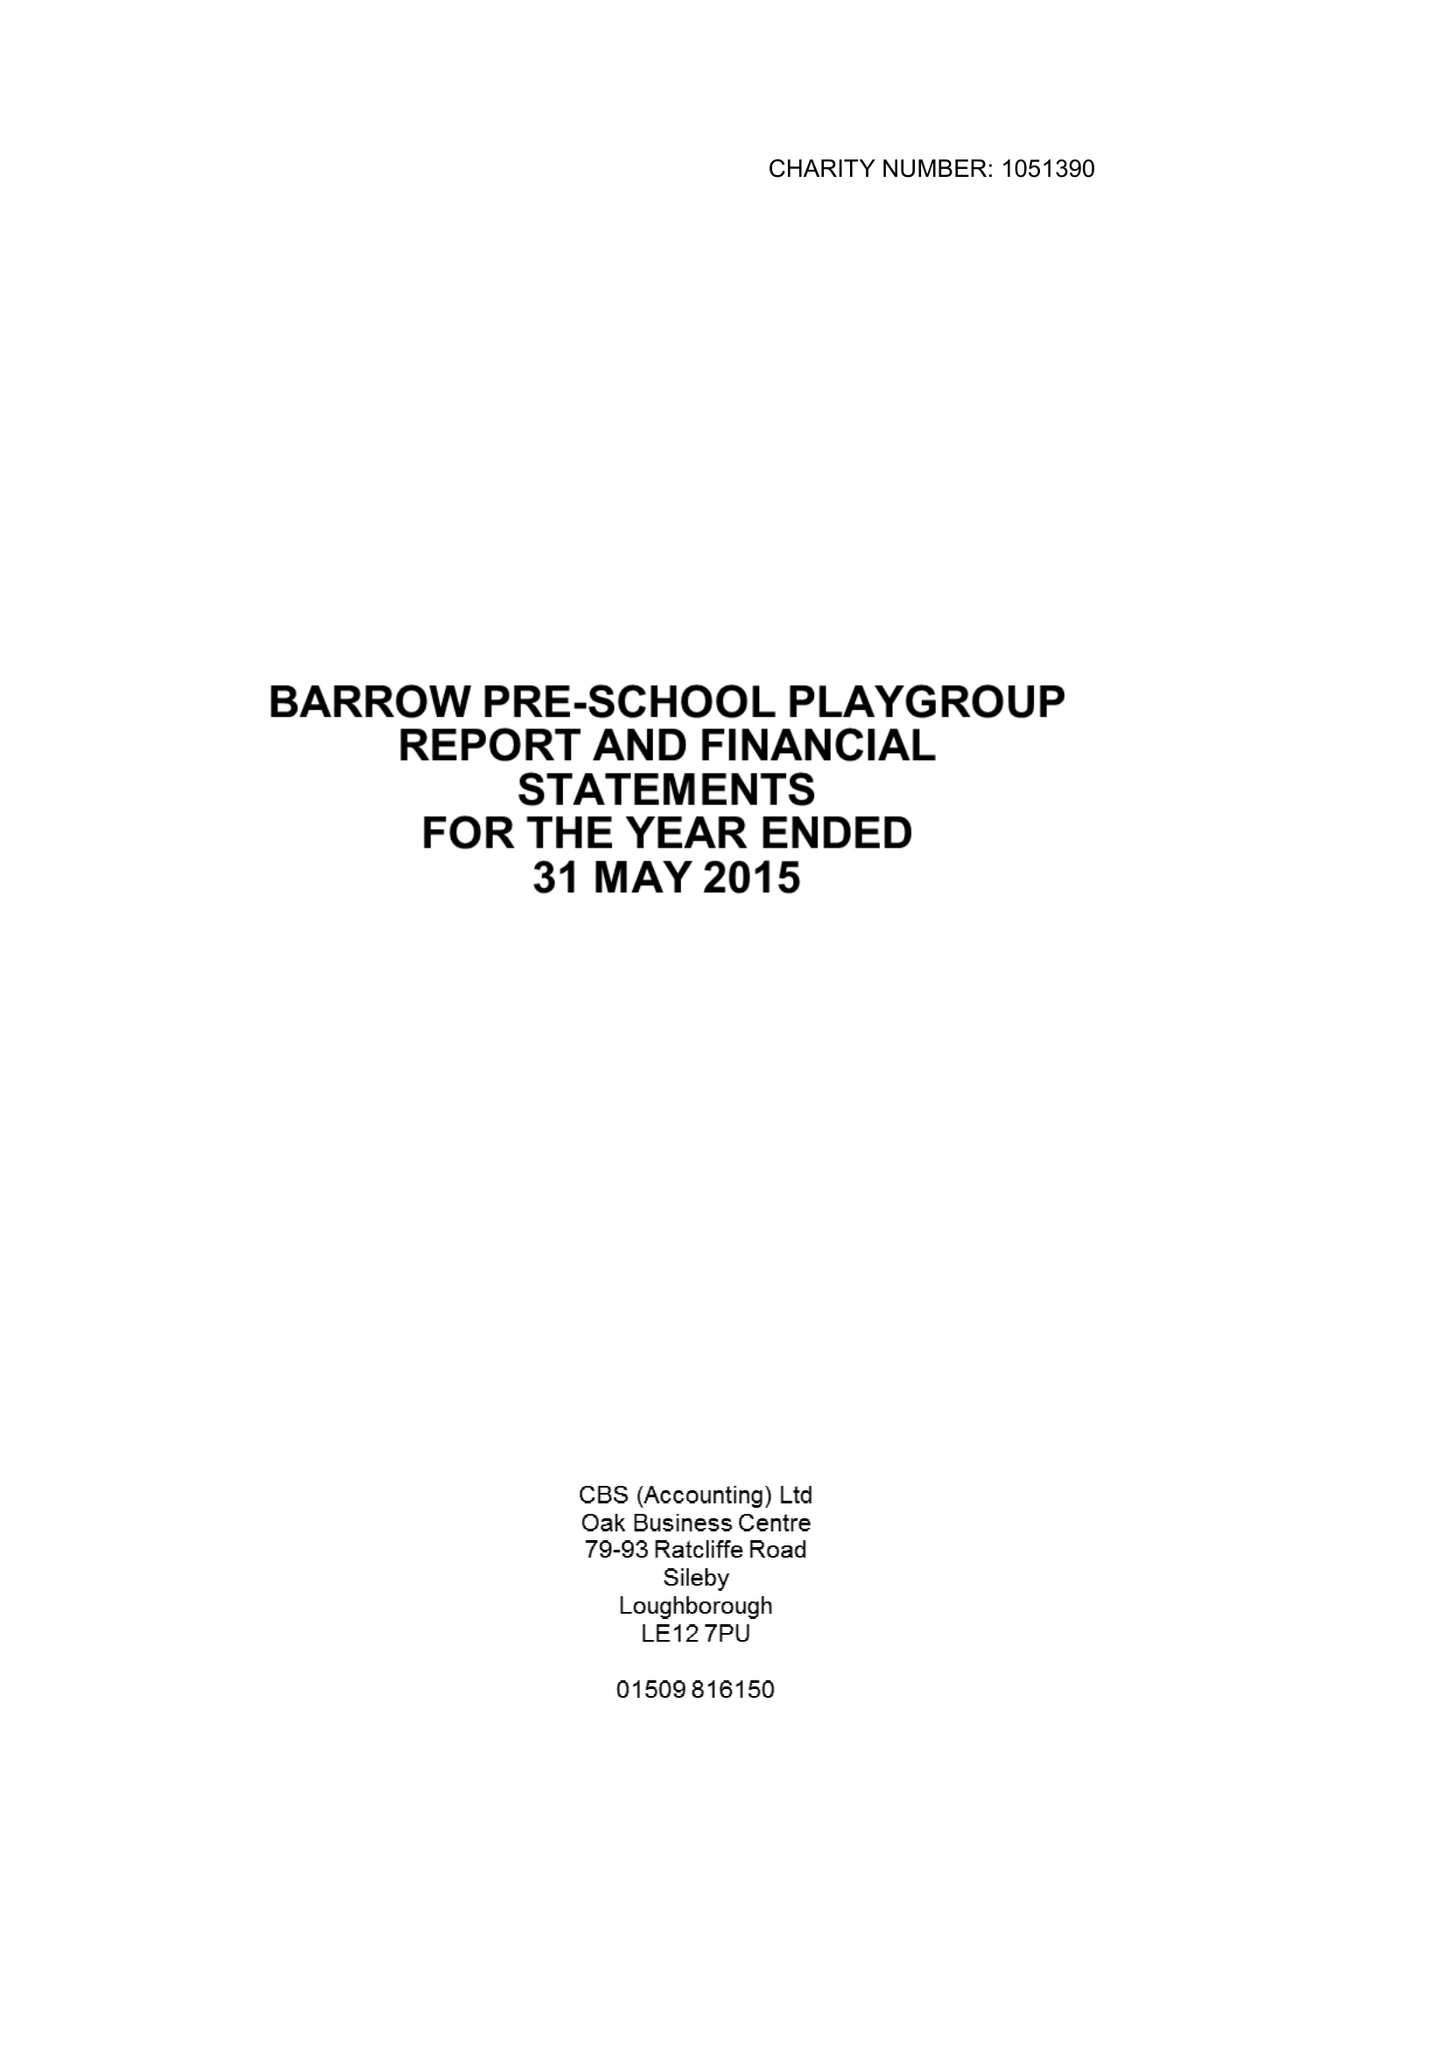What is the value for the address__post_town?
Answer the question using a single word or phrase. LOUGHBOROUGH 